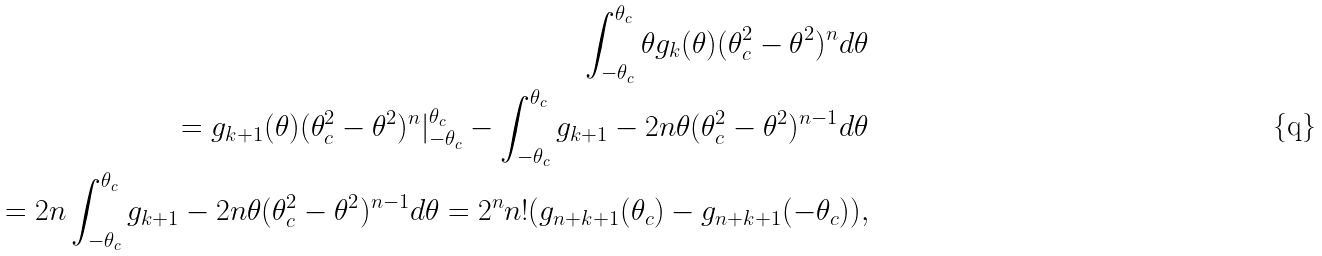<formula> <loc_0><loc_0><loc_500><loc_500>\int _ { - \theta _ { c } } ^ { \theta _ { c } } \theta g _ { k } ( \theta ) ( \theta _ { c } ^ { 2 } - \theta ^ { 2 } ) ^ { n } d \theta \\ = g _ { k + 1 } ( \theta ) ( \theta _ { c } ^ { 2 } - \theta ^ { 2 } ) ^ { n } | _ { - \theta _ { c } } ^ { \theta _ { c } } - \int _ { - \theta _ { c } } ^ { \theta _ { c } } g _ { k + 1 } - 2 n \theta ( \theta _ { c } ^ { 2 } - \theta ^ { 2 } ) ^ { n - 1 } d \theta \\ = 2 n \int _ { - \theta _ { c } } ^ { \theta _ { c } } g _ { k + 1 } - 2 n \theta ( \theta _ { c } ^ { 2 } - \theta ^ { 2 } ) ^ { n - 1 } d \theta = 2 ^ { n } n ! ( g _ { n + k + 1 } ( \theta _ { c } ) - g _ { n + k + 1 } ( - \theta _ { c } ) ) ,</formula> 